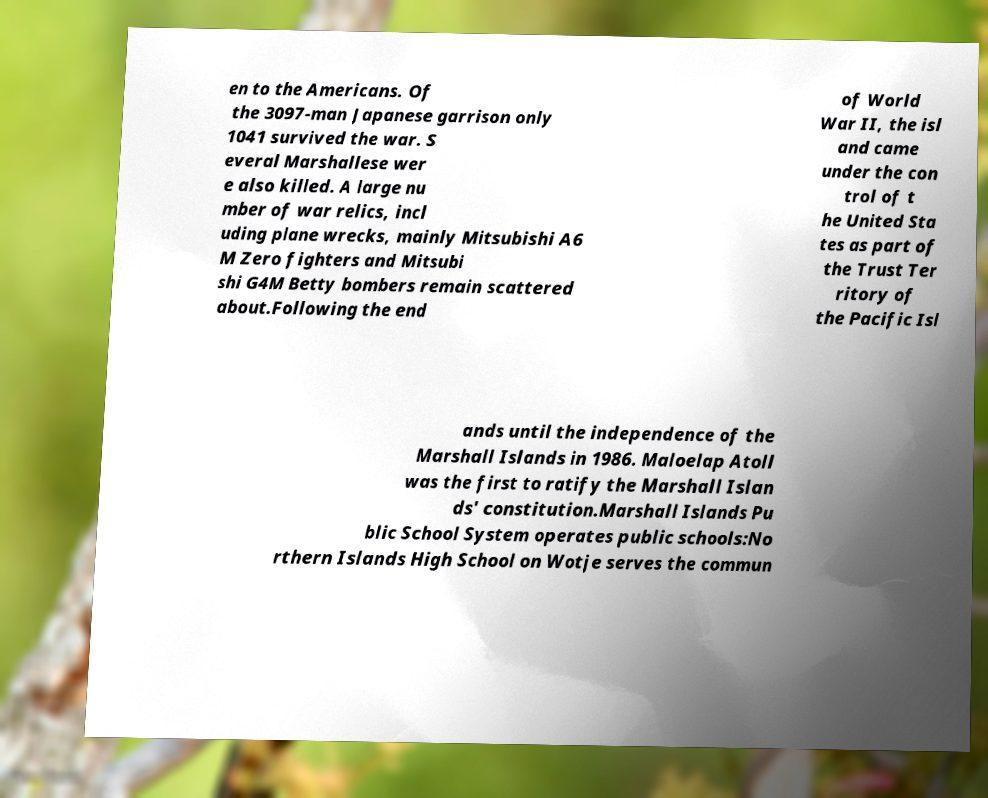What messages or text are displayed in this image? I need them in a readable, typed format. en to the Americans. Of the 3097-man Japanese garrison only 1041 survived the war. S everal Marshallese wer e also killed. A large nu mber of war relics, incl uding plane wrecks, mainly Mitsubishi A6 M Zero fighters and Mitsubi shi G4M Betty bombers remain scattered about.Following the end of World War II, the isl and came under the con trol of t he United Sta tes as part of the Trust Ter ritory of the Pacific Isl ands until the independence of the Marshall Islands in 1986. Maloelap Atoll was the first to ratify the Marshall Islan ds' constitution.Marshall Islands Pu blic School System operates public schools:No rthern Islands High School on Wotje serves the commun 